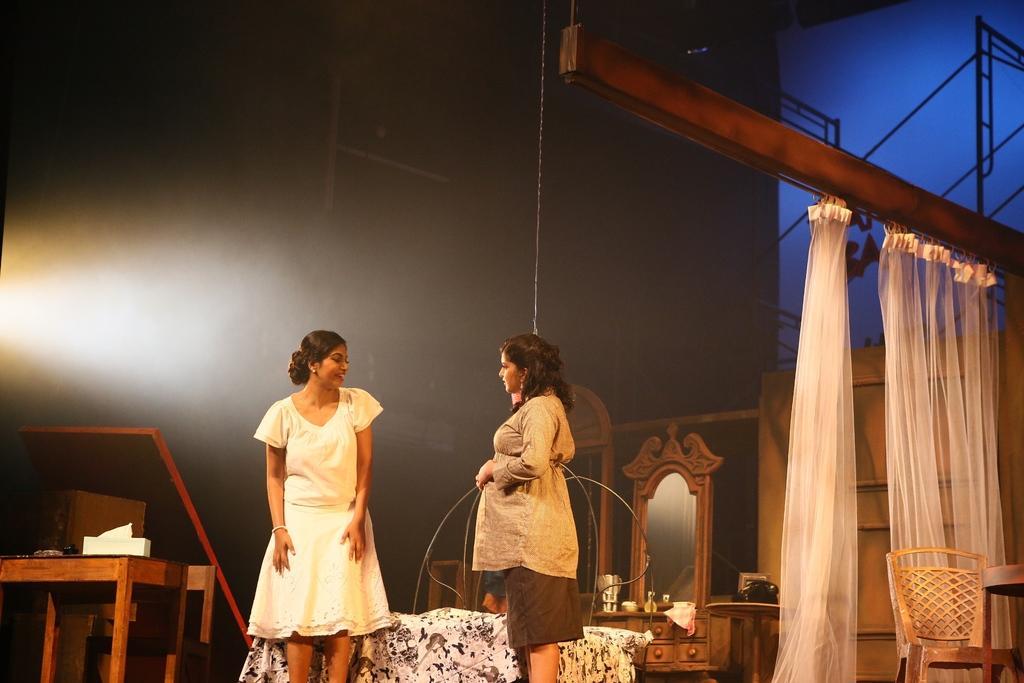In one or two sentences, can you explain what this image depicts? In this picture we can see two women's are standing and talking with each other back of them their is a bed covered with white color cloth in the left side we can see a table some tissues are been placed and the right side we can see dressing table and one chair and some clots are being hanged. 